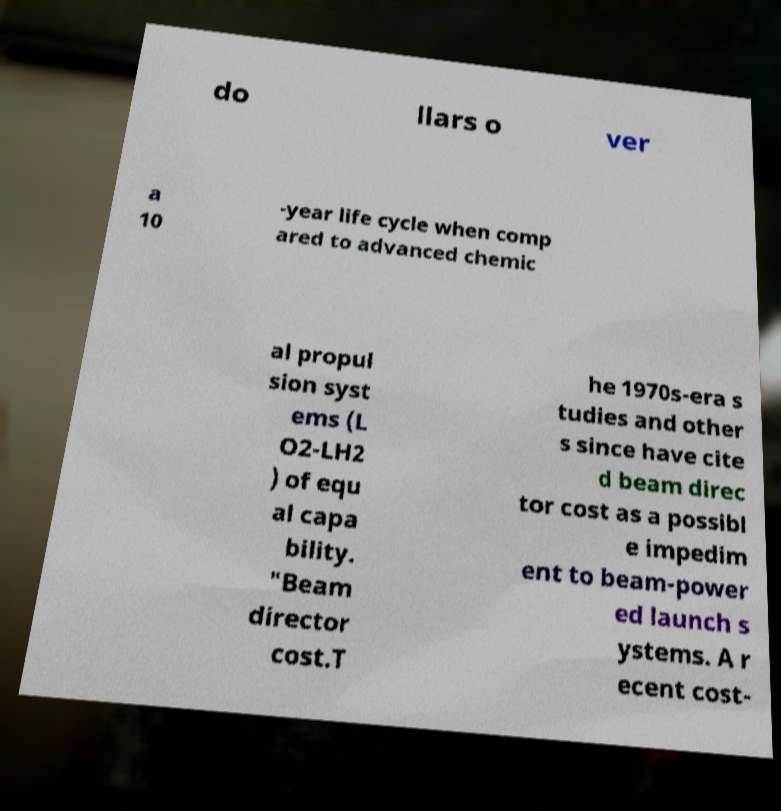Can you read and provide the text displayed in the image?This photo seems to have some interesting text. Can you extract and type it out for me? do llars o ver a 10 -year life cycle when comp ared to advanced chemic al propul sion syst ems (L O2-LH2 ) of equ al capa bility. "Beam director cost.T he 1970s-era s tudies and other s since have cite d beam direc tor cost as a possibl e impedim ent to beam-power ed launch s ystems. A r ecent cost- 